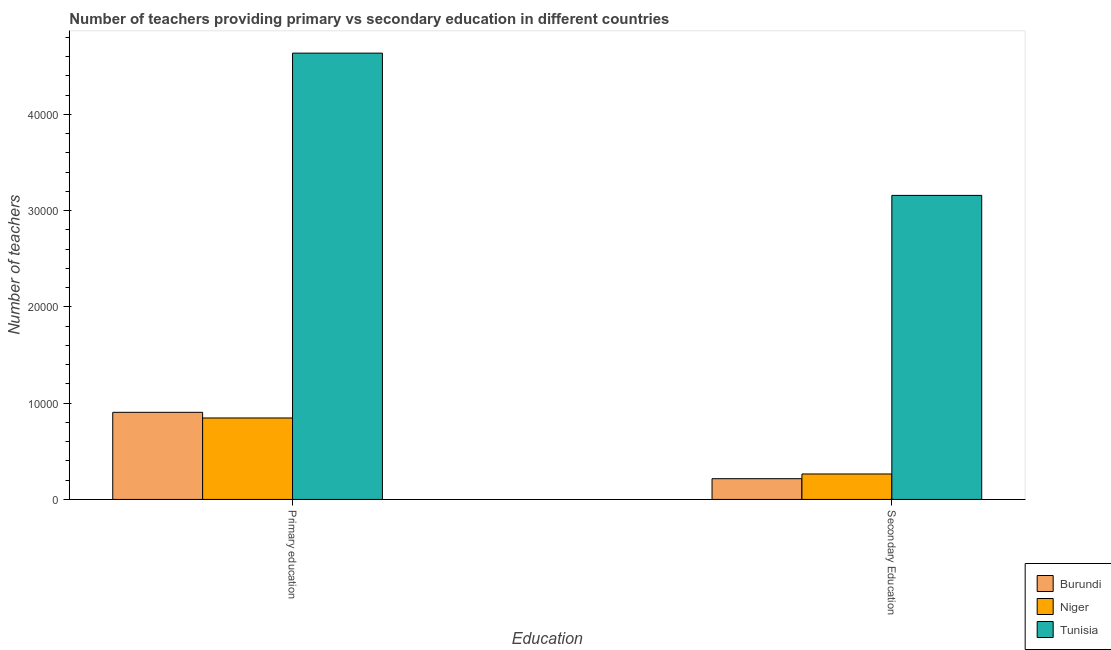How many different coloured bars are there?
Offer a terse response. 3. Are the number of bars per tick equal to the number of legend labels?
Your answer should be very brief. Yes. How many bars are there on the 1st tick from the left?
Keep it short and to the point. 3. How many bars are there on the 2nd tick from the right?
Provide a short and direct response. 3. What is the label of the 2nd group of bars from the left?
Give a very brief answer. Secondary Education. What is the number of primary teachers in Niger?
Make the answer very short. 8462. Across all countries, what is the maximum number of secondary teachers?
Keep it short and to the point. 3.16e+04. Across all countries, what is the minimum number of primary teachers?
Your answer should be very brief. 8462. In which country was the number of primary teachers maximum?
Give a very brief answer. Tunisia. In which country was the number of secondary teachers minimum?
Offer a very short reply. Burundi. What is the total number of primary teachers in the graph?
Provide a short and direct response. 6.39e+04. What is the difference between the number of secondary teachers in Tunisia and that in Burundi?
Offer a very short reply. 2.94e+04. What is the difference between the number of primary teachers in Niger and the number of secondary teachers in Tunisia?
Offer a very short reply. -2.31e+04. What is the average number of secondary teachers per country?
Provide a short and direct response. 1.21e+04. What is the difference between the number of secondary teachers and number of primary teachers in Tunisia?
Provide a succinct answer. -1.48e+04. In how many countries, is the number of secondary teachers greater than 20000 ?
Make the answer very short. 1. What is the ratio of the number of primary teachers in Burundi to that in Tunisia?
Offer a terse response. 0.2. Is the number of secondary teachers in Niger less than that in Burundi?
Keep it short and to the point. No. In how many countries, is the number of secondary teachers greater than the average number of secondary teachers taken over all countries?
Provide a succinct answer. 1. What does the 3rd bar from the left in Primary education represents?
Offer a terse response. Tunisia. What does the 3rd bar from the right in Secondary Education represents?
Keep it short and to the point. Burundi. Are the values on the major ticks of Y-axis written in scientific E-notation?
Give a very brief answer. No. Does the graph contain grids?
Your answer should be very brief. No. How many legend labels are there?
Keep it short and to the point. 3. How are the legend labels stacked?
Make the answer very short. Vertical. What is the title of the graph?
Give a very brief answer. Number of teachers providing primary vs secondary education in different countries. What is the label or title of the X-axis?
Your response must be concise. Education. What is the label or title of the Y-axis?
Offer a very short reply. Number of teachers. What is the Number of teachers of Burundi in Primary education?
Provide a succinct answer. 9049. What is the Number of teachers in Niger in Primary education?
Give a very brief answer. 8462. What is the Number of teachers in Tunisia in Primary education?
Ensure brevity in your answer.  4.64e+04. What is the Number of teachers in Burundi in Secondary Education?
Give a very brief answer. 2153. What is the Number of teachers in Niger in Secondary Education?
Your response must be concise. 2644. What is the Number of teachers of Tunisia in Secondary Education?
Keep it short and to the point. 3.16e+04. Across all Education, what is the maximum Number of teachers of Burundi?
Give a very brief answer. 9049. Across all Education, what is the maximum Number of teachers in Niger?
Your answer should be very brief. 8462. Across all Education, what is the maximum Number of teachers in Tunisia?
Provide a short and direct response. 4.64e+04. Across all Education, what is the minimum Number of teachers of Burundi?
Make the answer very short. 2153. Across all Education, what is the minimum Number of teachers in Niger?
Keep it short and to the point. 2644. Across all Education, what is the minimum Number of teachers of Tunisia?
Keep it short and to the point. 3.16e+04. What is the total Number of teachers of Burundi in the graph?
Your answer should be compact. 1.12e+04. What is the total Number of teachers of Niger in the graph?
Provide a short and direct response. 1.11e+04. What is the total Number of teachers in Tunisia in the graph?
Give a very brief answer. 7.80e+04. What is the difference between the Number of teachers in Burundi in Primary education and that in Secondary Education?
Keep it short and to the point. 6896. What is the difference between the Number of teachers in Niger in Primary education and that in Secondary Education?
Your response must be concise. 5818. What is the difference between the Number of teachers of Tunisia in Primary education and that in Secondary Education?
Make the answer very short. 1.48e+04. What is the difference between the Number of teachers in Burundi in Primary education and the Number of teachers in Niger in Secondary Education?
Keep it short and to the point. 6405. What is the difference between the Number of teachers in Burundi in Primary education and the Number of teachers in Tunisia in Secondary Education?
Make the answer very short. -2.25e+04. What is the difference between the Number of teachers of Niger in Primary education and the Number of teachers of Tunisia in Secondary Education?
Your answer should be very brief. -2.31e+04. What is the average Number of teachers of Burundi per Education?
Provide a succinct answer. 5601. What is the average Number of teachers of Niger per Education?
Offer a very short reply. 5553. What is the average Number of teachers of Tunisia per Education?
Keep it short and to the point. 3.90e+04. What is the difference between the Number of teachers in Burundi and Number of teachers in Niger in Primary education?
Your answer should be very brief. 587. What is the difference between the Number of teachers of Burundi and Number of teachers of Tunisia in Primary education?
Make the answer very short. -3.73e+04. What is the difference between the Number of teachers in Niger and Number of teachers in Tunisia in Primary education?
Give a very brief answer. -3.79e+04. What is the difference between the Number of teachers in Burundi and Number of teachers in Niger in Secondary Education?
Make the answer very short. -491. What is the difference between the Number of teachers in Burundi and Number of teachers in Tunisia in Secondary Education?
Make the answer very short. -2.94e+04. What is the difference between the Number of teachers of Niger and Number of teachers of Tunisia in Secondary Education?
Make the answer very short. -2.89e+04. What is the ratio of the Number of teachers of Burundi in Primary education to that in Secondary Education?
Offer a very short reply. 4.2. What is the ratio of the Number of teachers of Niger in Primary education to that in Secondary Education?
Offer a very short reply. 3.2. What is the ratio of the Number of teachers of Tunisia in Primary education to that in Secondary Education?
Make the answer very short. 1.47. What is the difference between the highest and the second highest Number of teachers in Burundi?
Offer a very short reply. 6896. What is the difference between the highest and the second highest Number of teachers in Niger?
Make the answer very short. 5818. What is the difference between the highest and the second highest Number of teachers in Tunisia?
Your answer should be compact. 1.48e+04. What is the difference between the highest and the lowest Number of teachers of Burundi?
Your answer should be compact. 6896. What is the difference between the highest and the lowest Number of teachers of Niger?
Your answer should be compact. 5818. What is the difference between the highest and the lowest Number of teachers in Tunisia?
Keep it short and to the point. 1.48e+04. 